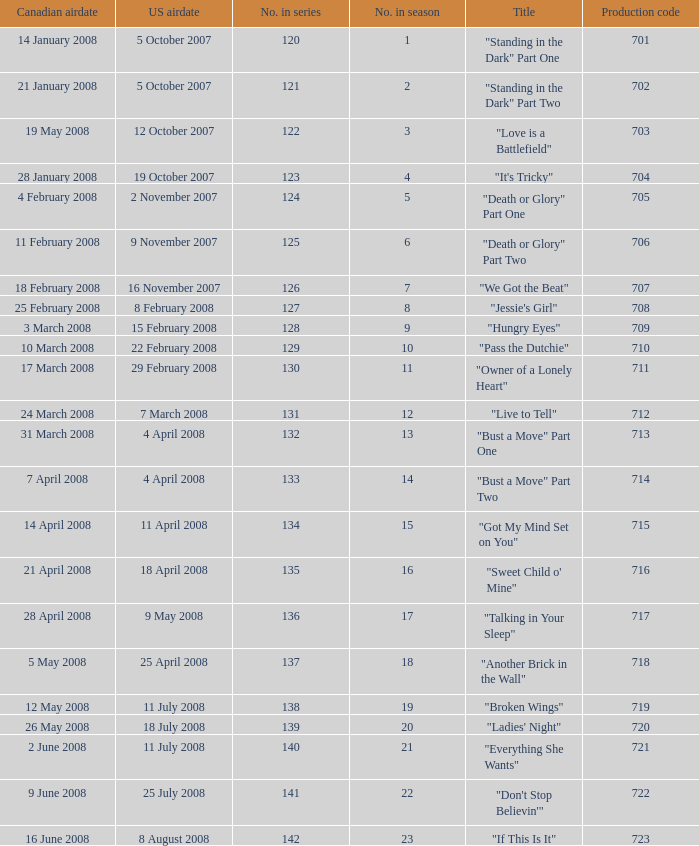The canadian airdate of 11 february 2008 applied to what series number? 1.0. 